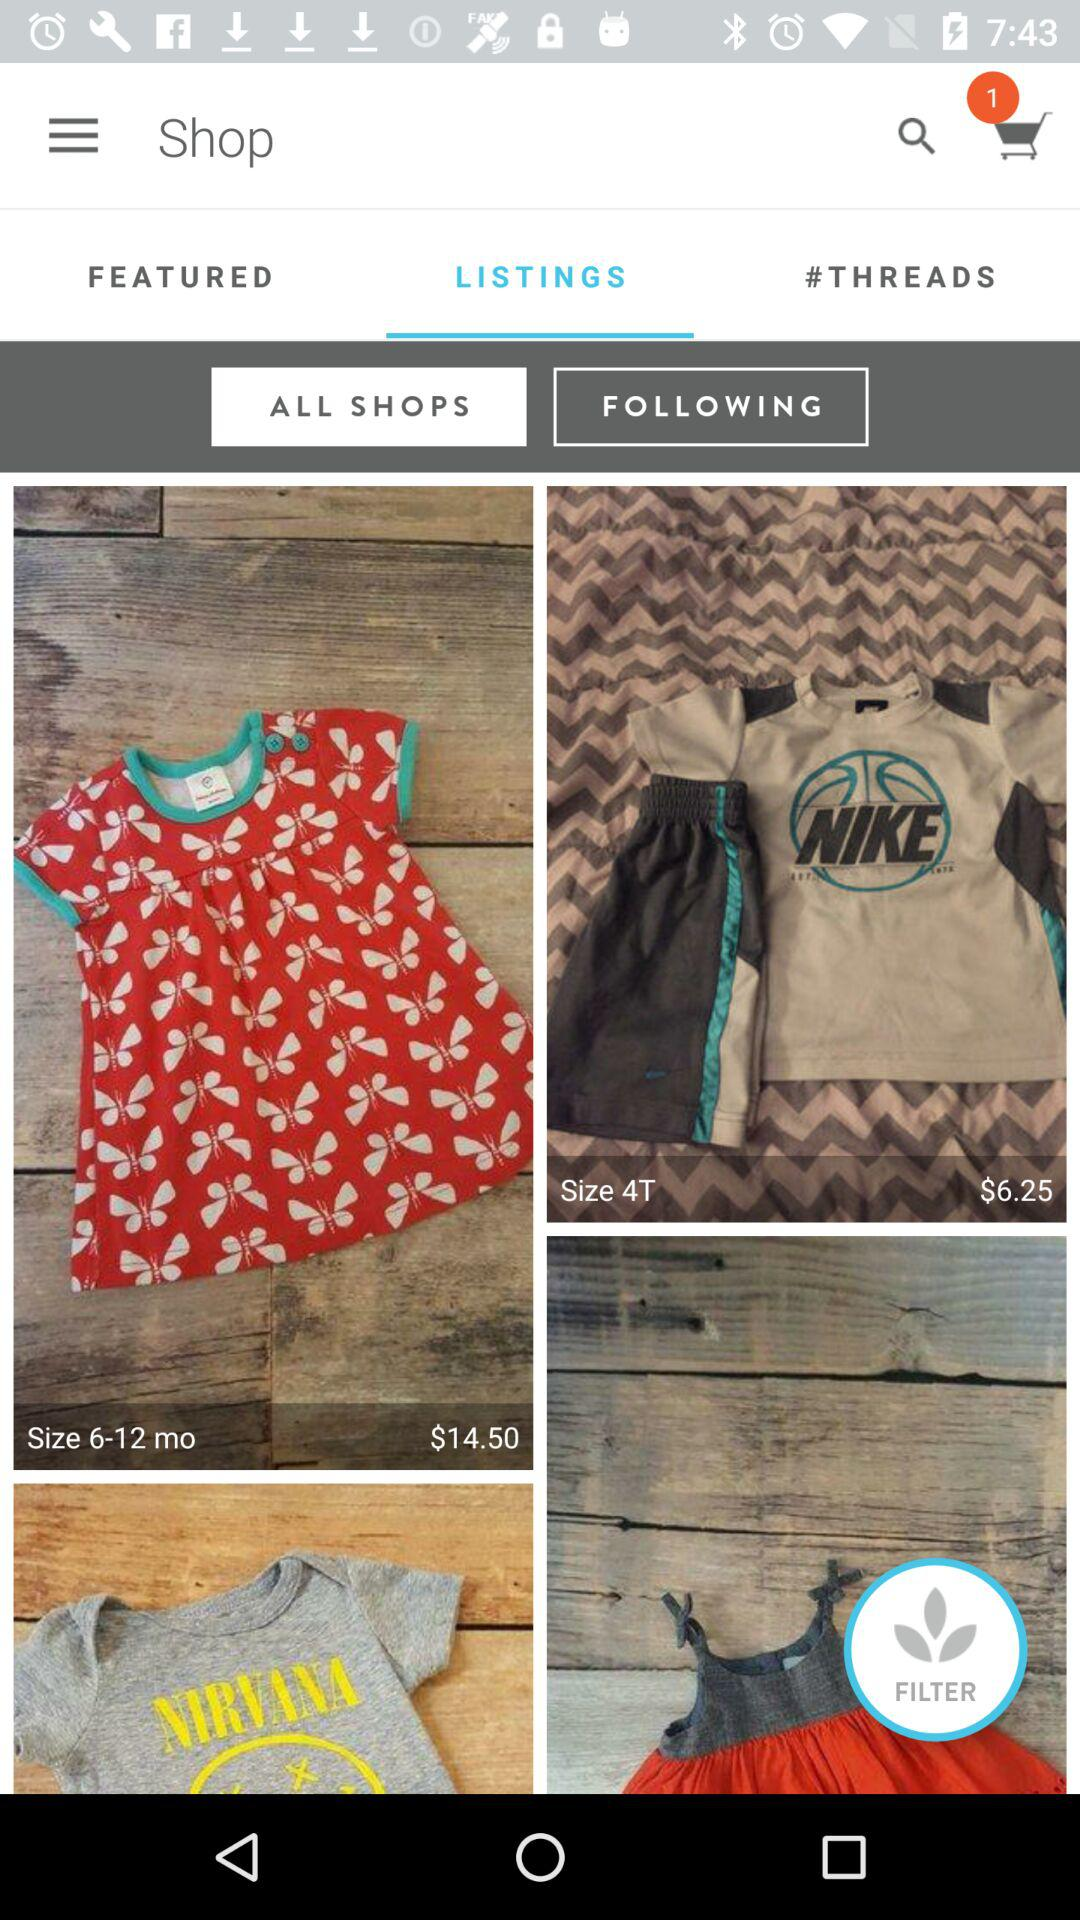What is the number of items added to the cart? The number of items added to the cart is 1. 